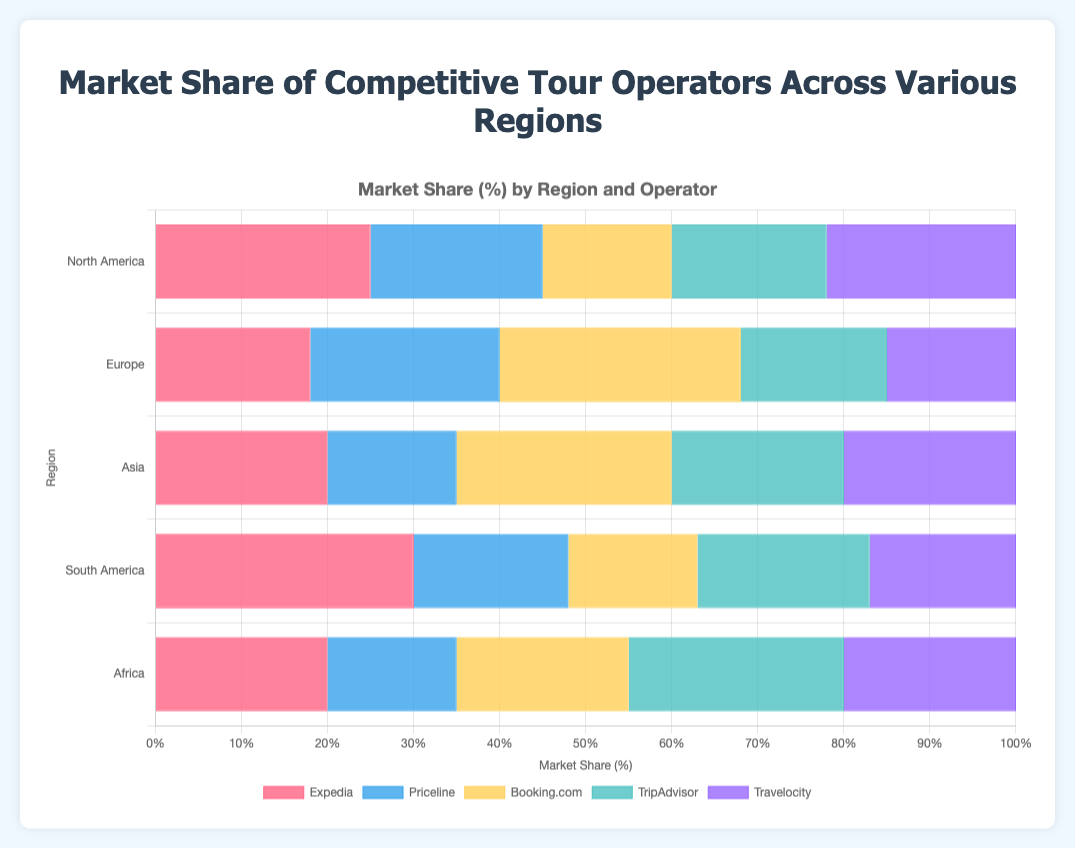What is the market share of Expedia in North America? Select the bar representing Expedia for North America and read the market share value from the figure.
Answer: 25% Which tour operator has the highest market share in Europe? Identify the tallest bar among the bars representing different tour operators in the Europe section. Booking.com has the tallest bar.
Answer: Booking.com Compare the market share of Priceline in Asia and South America. Which region has a higher share? Locate Priceline's bars for both Asia and South America and compare their heights. The bar for South America is taller.
Answer: South America Calculate the average market share of Booking.com across all regions. Sum Booking.com's market shares in all regions: 15 (North America) + 28 (Europe) + 25 (Asia) + 15 (South America) + 20 (Africa) = 103. Average = 103 / 5 = 20.6
Answer: 20.6 Which region has the lowest market share for TripAdvisor? Find TripAdvisor bars in each region and identify the shortest one. The shortest bar is in Europe with 17%.
Answer: Europe Does Travelocity have the same market share in any two regions? If yes, which ones? Check the heights of Travelocity bars across all regions to find identical heights. Yes, Travelocity has an equal market share of 20% in both Asia and Africa.
Answer: Asia and Africa What is the combined market share of Expedia and Travelocity in South America? Find Expedia’s and Travelocity’s market shares in South America from the figure and sum them: 30 + 17 = 47
Answer: 47 Which tour operator has the least market share in Africa? Locate the bars for Africa and identify the shortest one, which is for Priceline.
Answer: Priceline Calculate the difference in market share between TripAdvisor and Booking.com in Europe. Find the market shares for TripAdvisor and Booking.com in Europe. The difference is 28 - 17 = 11.
Answer: 11 